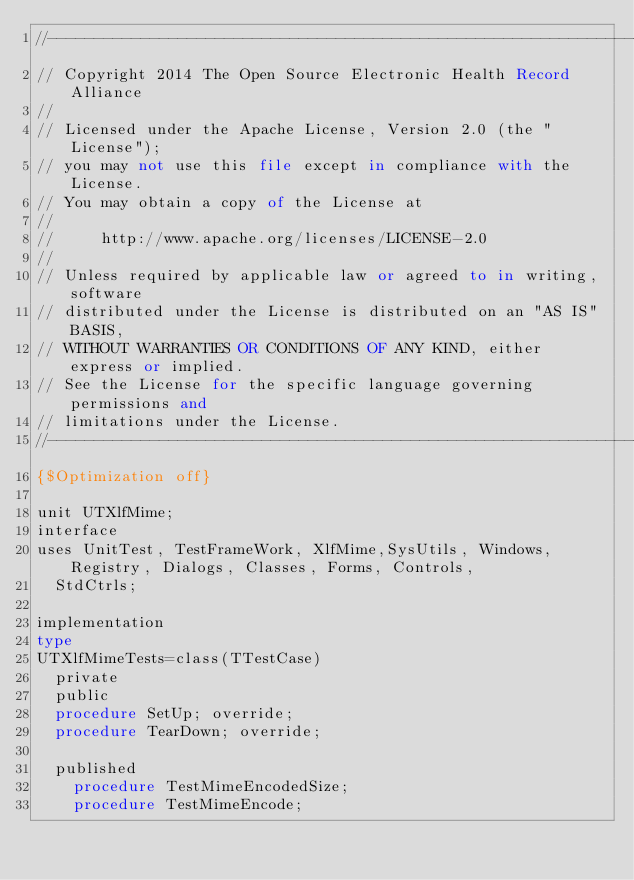Convert code to text. <code><loc_0><loc_0><loc_500><loc_500><_Pascal_>//---------------------------------------------------------------------------
// Copyright 2014 The Open Source Electronic Health Record Alliance
//
// Licensed under the Apache License, Version 2.0 (the "License");
// you may not use this file except in compliance with the License.
// You may obtain a copy of the License at
//
//     http://www.apache.org/licenses/LICENSE-2.0
//
// Unless required by applicable law or agreed to in writing, software
// distributed under the License is distributed on an "AS IS" BASIS,
// WITHOUT WARRANTIES OR CONDITIONS OF ANY KIND, either express or implied.
// See the License for the specific language governing permissions and
// limitations under the License.
//---------------------------------------------------------------------------
{$Optimization off}

unit UTXlfMime;
interface
uses UnitTest, TestFrameWork, XlfMime,SysUtils, Windows, Registry, Dialogs, Classes, Forms, Controls,
  StdCtrls;

implementation
type
UTXlfMimeTests=class(TTestCase)
  private
  public
  procedure SetUp; override;
  procedure TearDown; override;

  published
    procedure TestMimeEncodedSize;
    procedure TestMimeEncode;</code> 